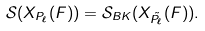<formula> <loc_0><loc_0><loc_500><loc_500>\mathcal { S } ( X _ { P _ { \ell } } ( F ) ) = \mathcal { S } _ { B K } ( X _ { \tilde { P } _ { \ell } } ( F ) ) .</formula> 